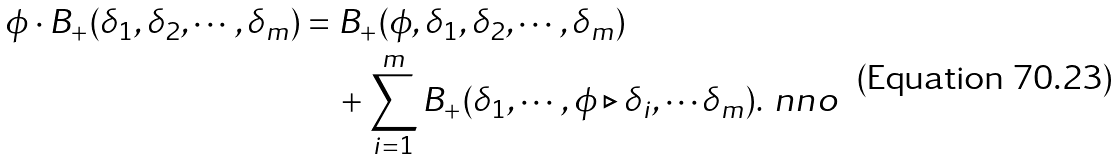Convert formula to latex. <formula><loc_0><loc_0><loc_500><loc_500>\phi \cdot B _ { + } ( \delta _ { 1 } , \delta _ { 2 } , \cdots , \delta _ { m } ) & = B _ { + } ( \phi , \delta _ { 1 } , \delta _ { 2 } , \cdots , \delta _ { m } ) \\ & \quad + \sum _ { i = 1 } ^ { m } B _ { + } ( \delta _ { 1 } , \cdots , \phi \triangleright \delta _ { i } , \cdots \delta _ { m } ) . \ n n o</formula> 